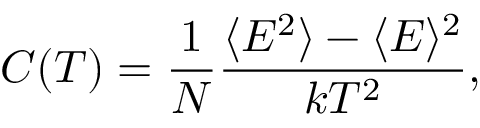<formula> <loc_0><loc_0><loc_500><loc_500>C ( T ) = \frac { 1 } { N } \frac { \langle E ^ { 2 } \rangle - \langle E \rangle ^ { 2 } } { k T ^ { 2 } } ,</formula> 